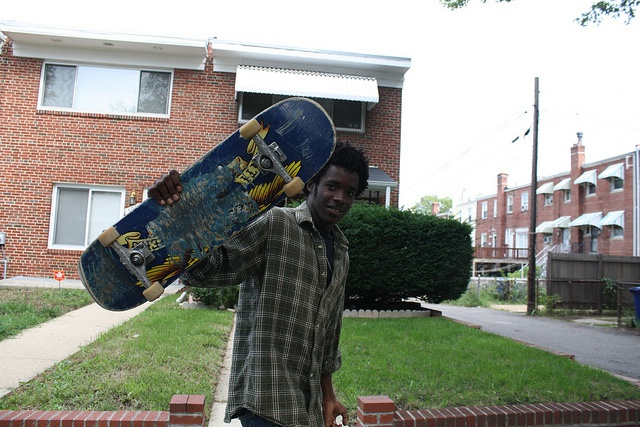Describe the objects in this image and their specific colors. I can see people in white, black, and gray tones and skateboard in white, black, navy, gray, and blue tones in this image. 